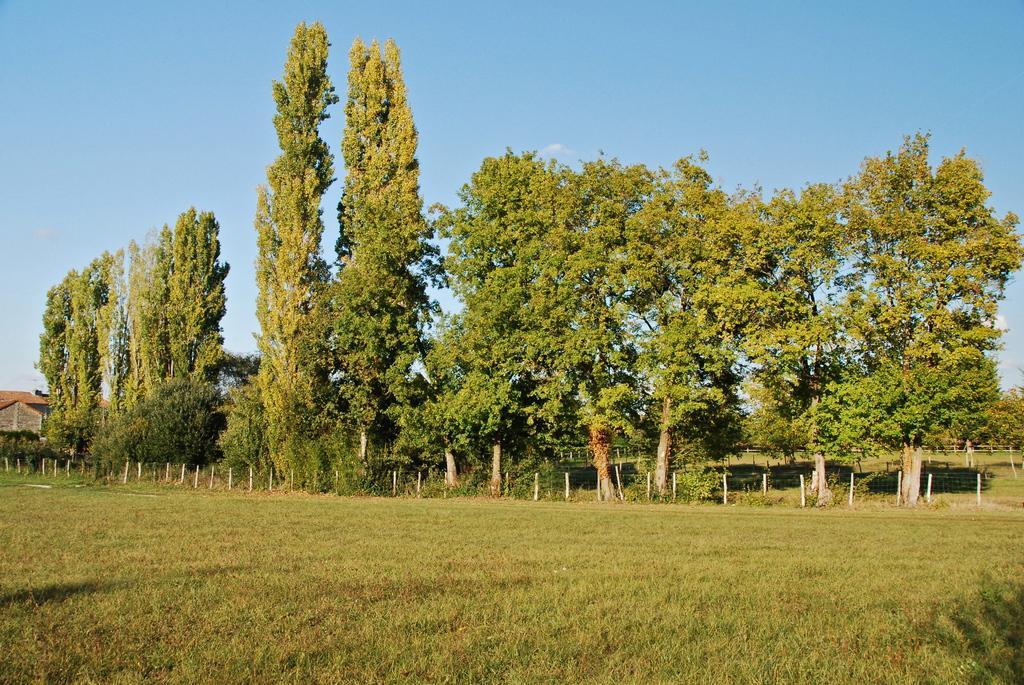Can you describe this image briefly? In the picture we can see a grass surface and in the background, we can see some fencing with a wire and poles and behind it we can see some trees, house and sky. 